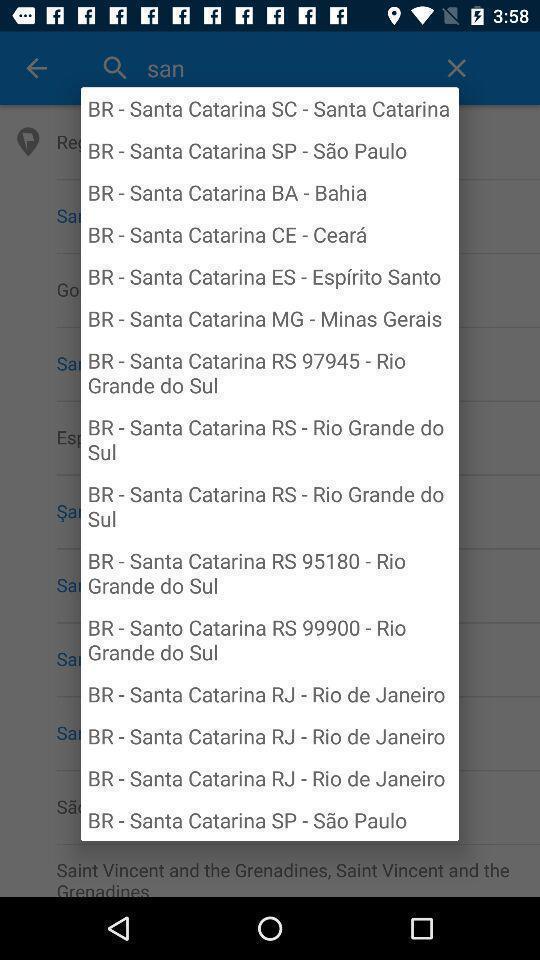Describe this image in words. Pop-up of a list of locations. 